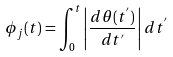<formula> <loc_0><loc_0><loc_500><loc_500>\phi _ { j } ( t ) = \int _ { 0 } ^ { t } \left | \frac { d \theta ( t ^ { ^ { \prime } } ) } { d t ^ { ^ { \prime } } } \right | d t ^ { ^ { \prime } }</formula> 